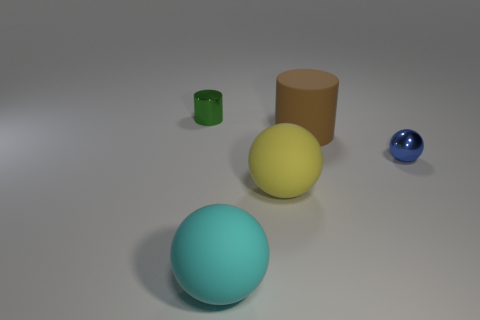Add 4 brown objects. How many objects exist? 9 Subtract 1 balls. How many balls are left? 2 Subtract all cylinders. How many objects are left? 3 Subtract all cyan rubber things. Subtract all cylinders. How many objects are left? 2 Add 4 brown objects. How many brown objects are left? 5 Add 1 yellow metallic things. How many yellow metallic things exist? 1 Subtract 0 brown spheres. How many objects are left? 5 